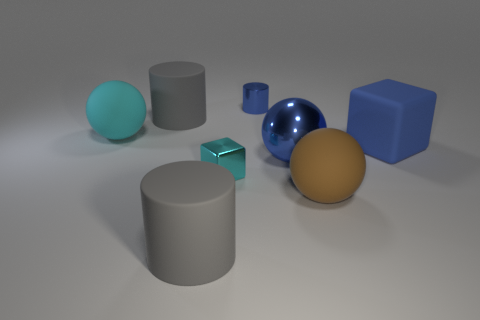Are there fewer big matte cubes that are in front of the big metallic object than rubber blocks?
Offer a very short reply. Yes. How many things are the same color as the big metal ball?
Provide a succinct answer. 2. There is a blue thing that is behind the large shiny sphere and in front of the tiny shiny cylinder; what material is it?
Provide a short and direct response. Rubber. There is a big rubber cylinder that is in front of the big rubber cube; does it have the same color as the block left of the blue block?
Provide a succinct answer. No. What number of blue objects are either small metal cylinders or shiny cubes?
Offer a terse response. 1. Are there fewer rubber blocks on the right side of the large cube than metal spheres behind the tiny blue metal thing?
Keep it short and to the point. No. Is there another blue block of the same size as the blue matte cube?
Your answer should be very brief. No. There is a matte cylinder in front of the rubber cube; is its size the same as the metal block?
Your answer should be compact. No. Is the number of metal spheres greater than the number of big red metal cylinders?
Ensure brevity in your answer.  Yes. Is there another small metal object of the same shape as the small blue thing?
Ensure brevity in your answer.  No. 